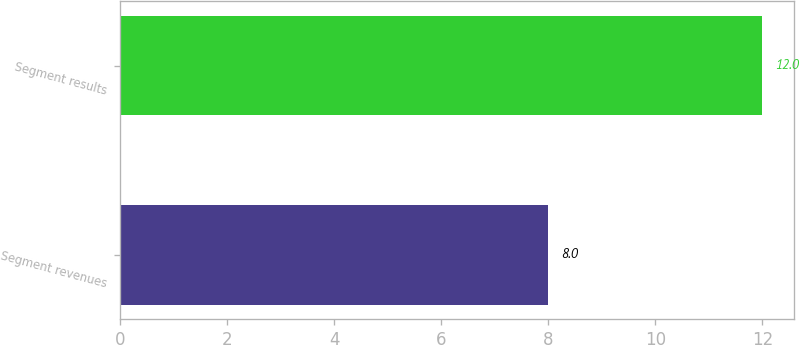Convert chart to OTSL. <chart><loc_0><loc_0><loc_500><loc_500><bar_chart><fcel>Segment revenues<fcel>Segment results<nl><fcel>8<fcel>12<nl></chart> 